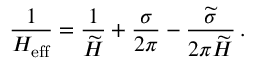Convert formula to latex. <formula><loc_0><loc_0><loc_500><loc_500>\frac { 1 } { H _ { e f f } } = \frac { 1 } { \widetilde { H } } + \frac { \sigma } { 2 \pi } - \frac { \widetilde { \sigma } } { 2 \pi \widetilde { H } } \, .</formula> 